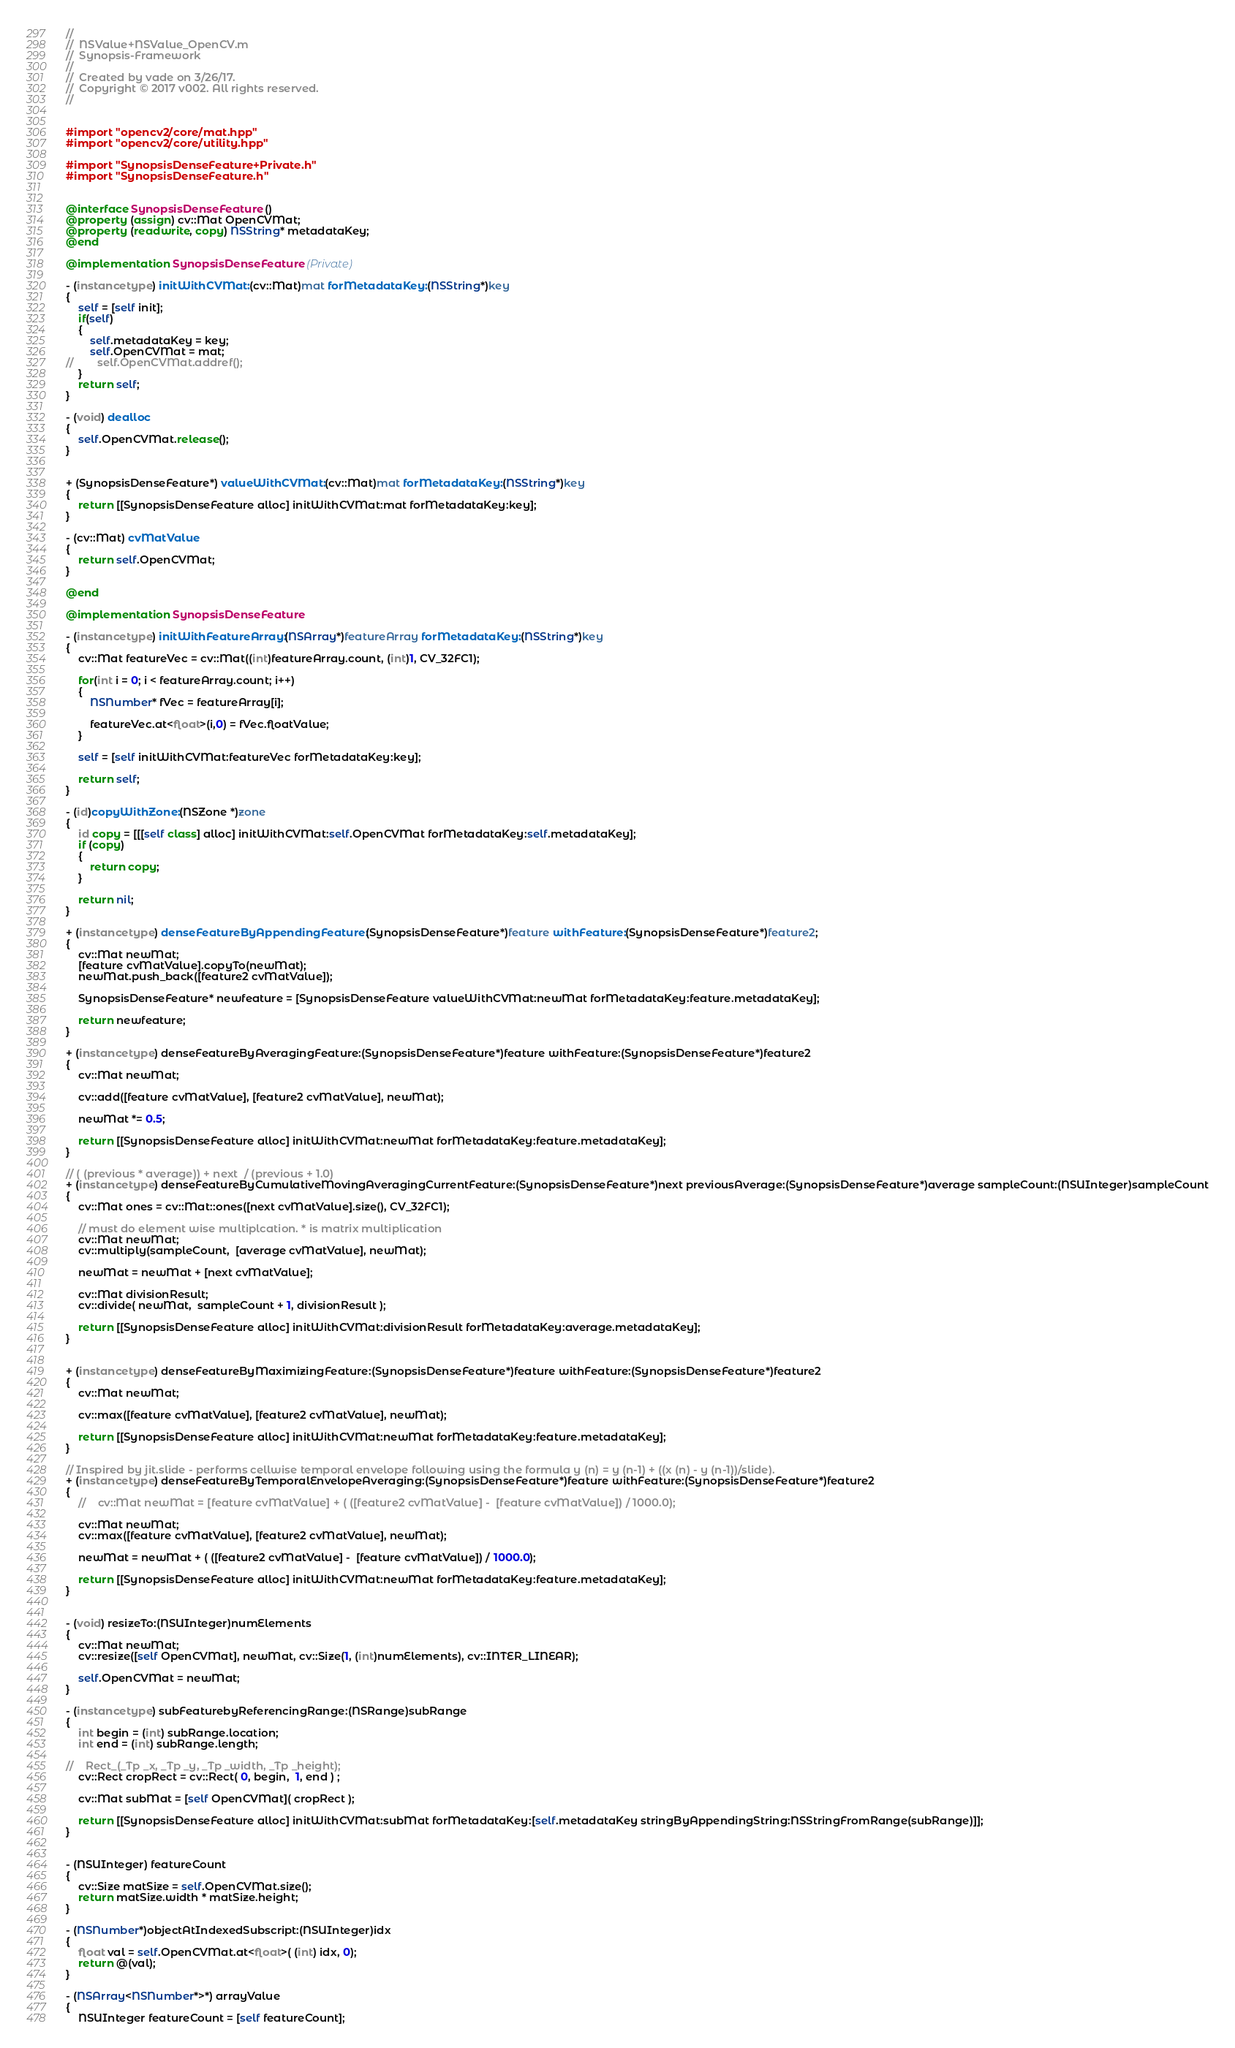Convert code to text. <code><loc_0><loc_0><loc_500><loc_500><_ObjectiveC_>//
//  NSValue+NSValue_OpenCV.m
//  Synopsis-Framework
//
//  Created by vade on 3/26/17.
//  Copyright © 2017 v002. All rights reserved.
//


#import "opencv2/core/mat.hpp"
#import "opencv2/core/utility.hpp"

#import "SynopsisDenseFeature+Private.h"
#import "SynopsisDenseFeature.h"


@interface SynopsisDenseFeature ()
@property (assign) cv::Mat OpenCVMat;
@property (readwrite, copy) NSString* metadataKey;
@end

@implementation SynopsisDenseFeature (Private)

- (instancetype) initWithCVMat:(cv::Mat)mat forMetadataKey:(NSString*)key
{
    self = [self init];
    if(self)
    {
        self.metadataKey = key;
        self.OpenCVMat = mat;
//        self.OpenCVMat.addref();
    }
    return self;
}

- (void) dealloc
{
    self.OpenCVMat.release();
}


+ (SynopsisDenseFeature*) valueWithCVMat:(cv::Mat)mat forMetadataKey:(NSString*)key
{
    return [[SynopsisDenseFeature alloc] initWithCVMat:mat forMetadataKey:key];
}

- (cv::Mat) cvMatValue
{
    return self.OpenCVMat;
}

@end

@implementation SynopsisDenseFeature

- (instancetype) initWithFeatureArray:(NSArray*)featureArray forMetadataKey:(NSString*)key
{
    cv::Mat featureVec = cv::Mat((int)featureArray.count, (int)1, CV_32FC1);
    
    for(int i = 0; i < featureArray.count; i++)
    {
        NSNumber* fVec = featureArray[i];
        
        featureVec.at<float>(i,0) = fVec.floatValue;
    }

    self = [self initWithCVMat:featureVec forMetadataKey:key];
    
    return self;
}

- (id)copyWithZone:(NSZone *)zone
{
    id copy = [[[self class] alloc] initWithCVMat:self.OpenCVMat forMetadataKey:self.metadataKey];
    if (copy)
    {
        return copy;
    }

    return nil;
}

+ (instancetype) denseFeatureByAppendingFeature:(SynopsisDenseFeature*)feature withFeature:(SynopsisDenseFeature*)feature2;
{
    cv::Mat newMat;
    [feature cvMatValue].copyTo(newMat);
    newMat.push_back([feature2 cvMatValue]);
    
    SynopsisDenseFeature* newfeature = [SynopsisDenseFeature valueWithCVMat:newMat forMetadataKey:feature.metadataKey];
    
    return newfeature;
}

+ (instancetype) denseFeatureByAveragingFeature:(SynopsisDenseFeature*)feature withFeature:(SynopsisDenseFeature*)feature2
{
    cv::Mat newMat;
    
    cv::add([feature cvMatValue], [feature2 cvMatValue], newMat);
    
    newMat *= 0.5;
    
    return [[SynopsisDenseFeature alloc] initWithCVMat:newMat forMetadataKey:feature.metadataKey];
}

// ( (previous * average)) + next  / (previous + 1.0)
+ (instancetype) denseFeatureByCumulativeMovingAveragingCurrentFeature:(SynopsisDenseFeature*)next previousAverage:(SynopsisDenseFeature*)average sampleCount:(NSUInteger)sampleCount
{
    cv::Mat ones = cv::Mat::ones([next cvMatValue].size(), CV_32FC1);
    
    // must do element wise multiplcation. * is matrix multiplication
    cv::Mat newMat;
    cv::multiply(sampleCount,  [average cvMatValue], newMat);
    
    newMat = newMat + [next cvMatValue];
    
    cv::Mat divisionResult;
    cv::divide( newMat,  sampleCount + 1, divisionResult );
    
    return [[SynopsisDenseFeature alloc] initWithCVMat:divisionResult forMetadataKey:average.metadataKey];
}


+ (instancetype) denseFeatureByMaximizingFeature:(SynopsisDenseFeature*)feature withFeature:(SynopsisDenseFeature*)feature2
{
    cv::Mat newMat;
    
    cv::max([feature cvMatValue], [feature2 cvMatValue], newMat);
    
    return [[SynopsisDenseFeature alloc] initWithCVMat:newMat forMetadataKey:feature.metadataKey];
}

// Inspired by jit.slide - performs cellwise temporal envelope following using the formula y (n) = y (n-1) + ((x (n) - y (n-1))/slide).
+ (instancetype) denseFeatureByTemporalEnvelopeAveraging:(SynopsisDenseFeature*)feature withFeature:(SynopsisDenseFeature*)feature2
{
    //    cv::Mat newMat = [feature cvMatValue] + ( ([feature2 cvMatValue] -  [feature cvMatValue]) / 1000.0);

    cv::Mat newMat;
    cv::max([feature cvMatValue], [feature2 cvMatValue], newMat);
    
    newMat = newMat + ( ([feature2 cvMatValue] -  [feature cvMatValue]) / 1000.0);

    return [[SynopsisDenseFeature alloc] initWithCVMat:newMat forMetadataKey:feature.metadataKey];
}


- (void) resizeTo:(NSUInteger)numElements
{
    cv::Mat newMat;
    cv::resize([self OpenCVMat], newMat, cv::Size(1, (int)numElements), cv::INTER_LINEAR);
    
    self.OpenCVMat = newMat;
}

- (instancetype) subFeaturebyReferencingRange:(NSRange)subRange
{
    int begin = (int) subRange.location;
    int end = (int) subRange.length;
  
//    Rect_(_Tp _x, _Tp _y, _Tp _width, _Tp _height);
    cv::Rect cropRect = cv::Rect( 0, begin,  1, end ) ;
    
    cv::Mat subMat = [self OpenCVMat]( cropRect );

    return [[SynopsisDenseFeature alloc] initWithCVMat:subMat forMetadataKey:[self.metadataKey stringByAppendingString:NSStringFromRange(subRange)]];
}


- (NSUInteger) featureCount
{
    cv::Size matSize = self.OpenCVMat.size();
    return matSize.width * matSize.height;
}

- (NSNumber*)objectAtIndexedSubscript:(NSUInteger)idx
{
    float val = self.OpenCVMat.at<float>( (int) idx, 0);
    return @(val);
}

- (NSArray<NSNumber*>*) arrayValue
{
    NSUInteger featureCount = [self featureCount];</code> 